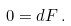Convert formula to latex. <formula><loc_0><loc_0><loc_500><loc_500>0 = d F \, .</formula> 